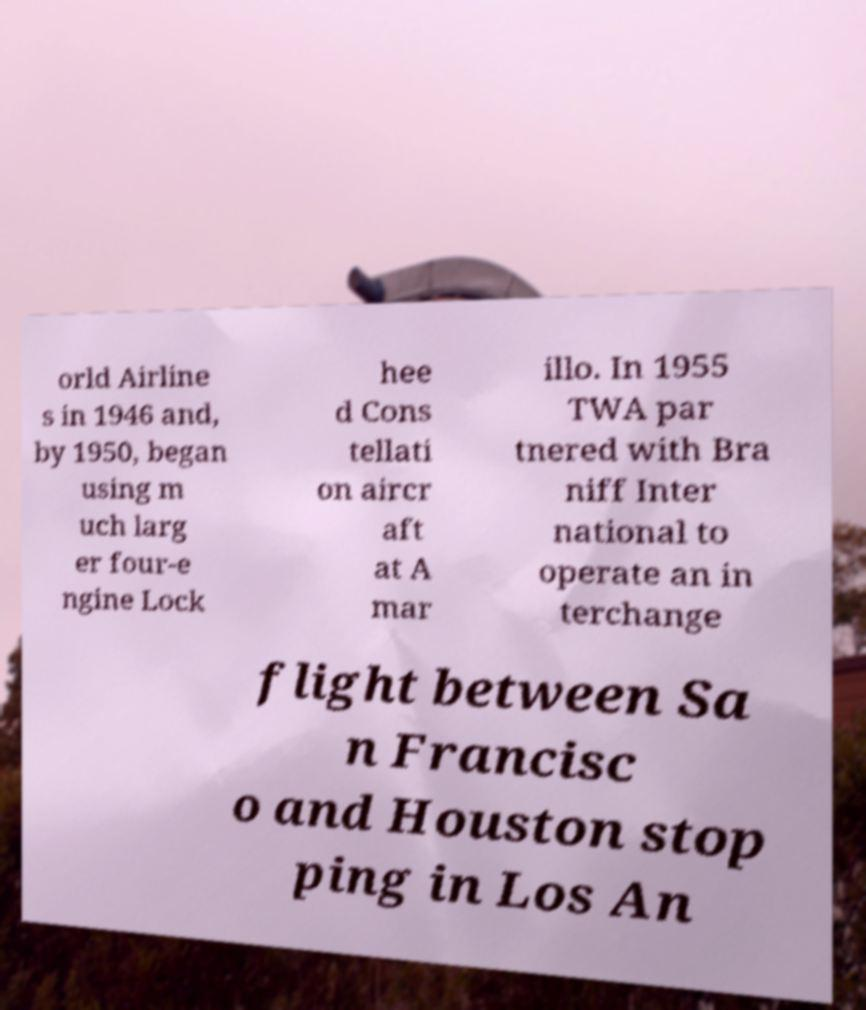Could you extract and type out the text from this image? orld Airline s in 1946 and, by 1950, began using m uch larg er four-e ngine Lock hee d Cons tellati on aircr aft at A mar illo. In 1955 TWA par tnered with Bra niff Inter national to operate an in terchange flight between Sa n Francisc o and Houston stop ping in Los An 